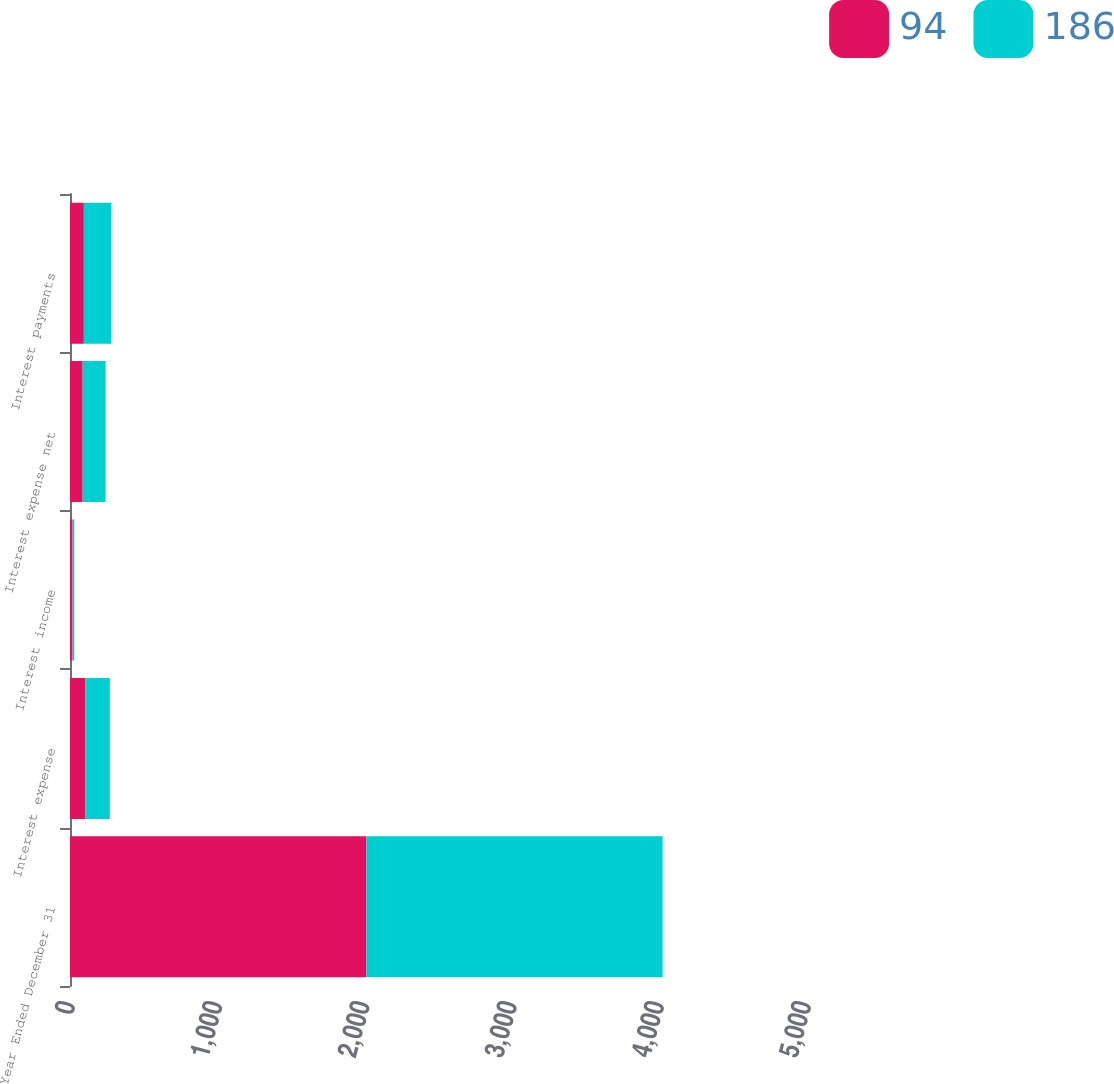Convert chart to OTSL. <chart><loc_0><loc_0><loc_500><loc_500><stacked_bar_chart><ecel><fcel>Year Ended December 31<fcel>Interest expense<fcel>Interest income<fcel>Interest expense net<fcel>Interest payments<nl><fcel>94<fcel>2014<fcel>103<fcel>17<fcel>86<fcel>94<nl><fcel>186<fcel>2012<fcel>168<fcel>12<fcel>156<fcel>186<nl></chart> 